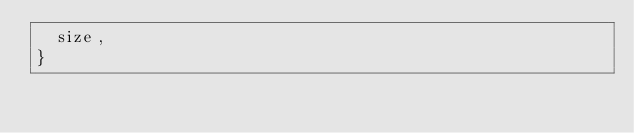Convert code to text. <code><loc_0><loc_0><loc_500><loc_500><_Dart_>  size,
}
</code> 